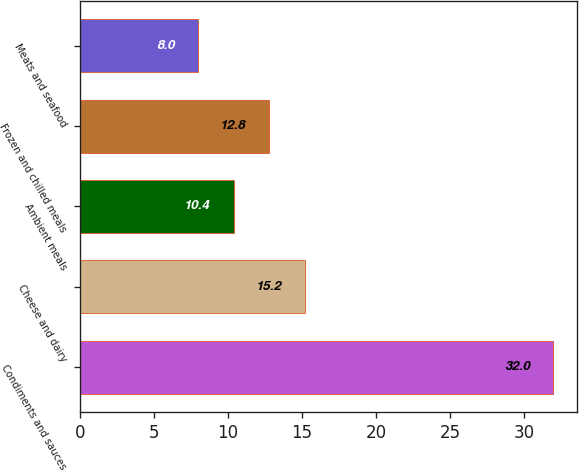<chart> <loc_0><loc_0><loc_500><loc_500><bar_chart><fcel>Condiments and sauces<fcel>Cheese and dairy<fcel>Ambient meals<fcel>Frozen and chilled meals<fcel>Meats and seafood<nl><fcel>32<fcel>15.2<fcel>10.4<fcel>12.8<fcel>8<nl></chart> 